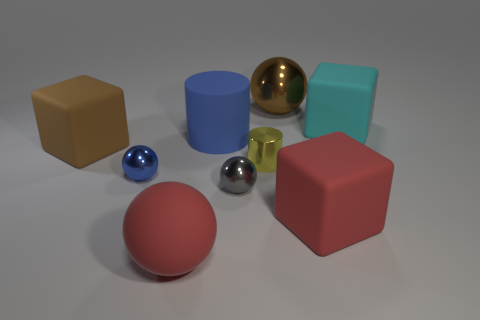Add 1 big cyan rubber cubes. How many objects exist? 10 Subtract all cylinders. How many objects are left? 7 Subtract 0 purple blocks. How many objects are left? 9 Subtract all tiny yellow shiny cylinders. Subtract all big cylinders. How many objects are left? 7 Add 1 tiny gray things. How many tiny gray things are left? 2 Add 6 green matte spheres. How many green matte spheres exist? 6 